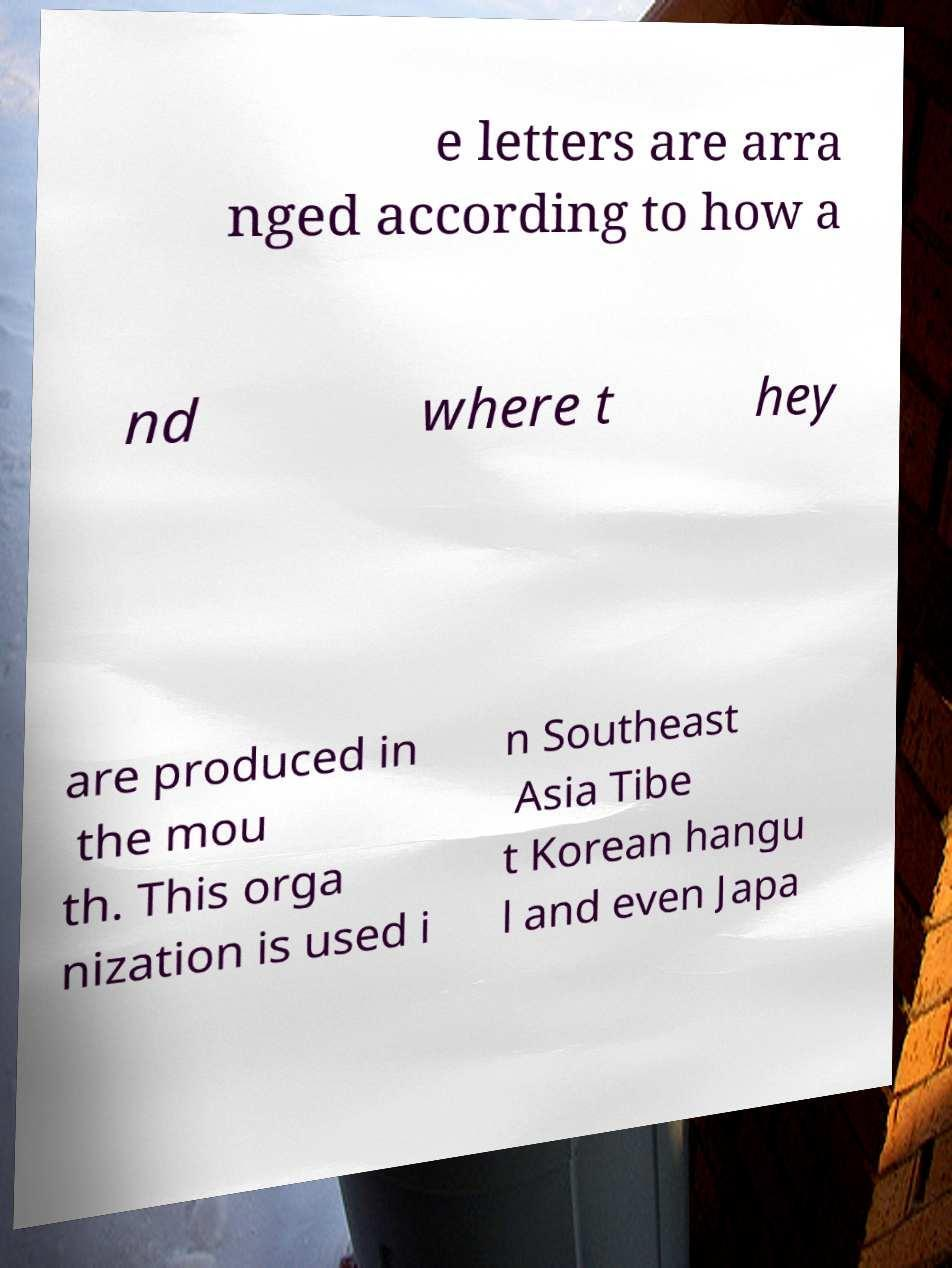What messages or text are displayed in this image? I need them in a readable, typed format. e letters are arra nged according to how a nd where t hey are produced in the mou th. This orga nization is used i n Southeast Asia Tibe t Korean hangu l and even Japa 